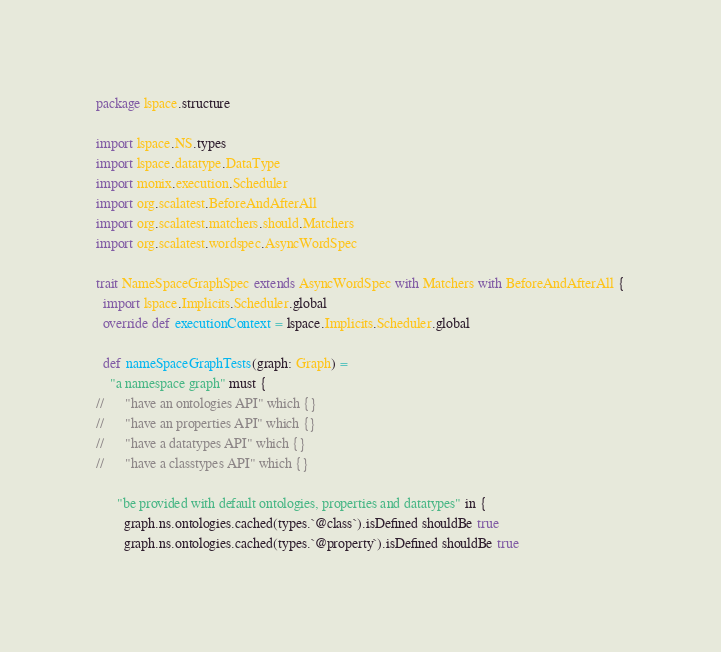Convert code to text. <code><loc_0><loc_0><loc_500><loc_500><_Scala_>package lspace.structure

import lspace.NS.types
import lspace.datatype.DataType
import monix.execution.Scheduler
import org.scalatest.BeforeAndAfterAll
import org.scalatest.matchers.should.Matchers
import org.scalatest.wordspec.AsyncWordSpec

trait NameSpaceGraphSpec extends AsyncWordSpec with Matchers with BeforeAndAfterAll {
  import lspace.Implicits.Scheduler.global
  override def executionContext = lspace.Implicits.Scheduler.global

  def nameSpaceGraphTests(graph: Graph) =
    "a namespace graph" must {
//      "have an ontologies API" which {}
//      "have an properties API" which {}
//      "have a datatypes API" which {}
//      "have a classtypes API" which {}

      "be provided with default ontologies, properties and datatypes" in {
        graph.ns.ontologies.cached(types.`@class`).isDefined shouldBe true
        graph.ns.ontologies.cached(types.`@property`).isDefined shouldBe true</code> 